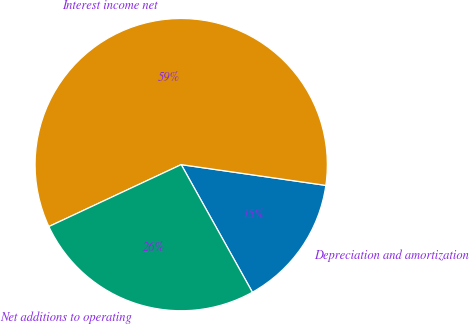Convert chart to OTSL. <chart><loc_0><loc_0><loc_500><loc_500><pie_chart><fcel>Depreciation and amortization<fcel>Interest income net<fcel>Net additions to operating<nl><fcel>14.63%<fcel>59.23%<fcel>26.13%<nl></chart> 